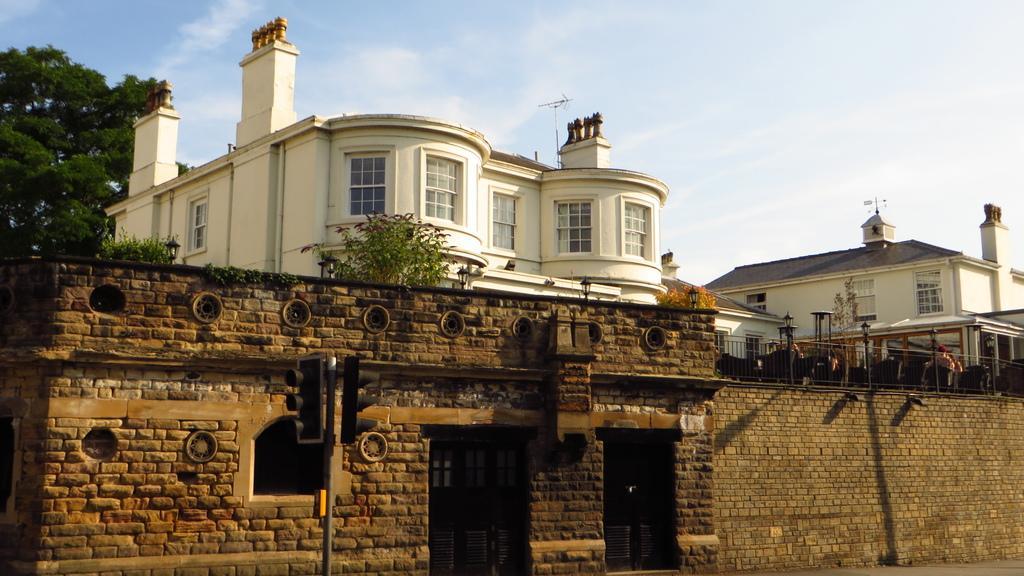Could you give a brief overview of what you see in this image? In this image I can see buildings, trees, plants, light poles, railing, signal lights, people, cloudy sky and objects. 